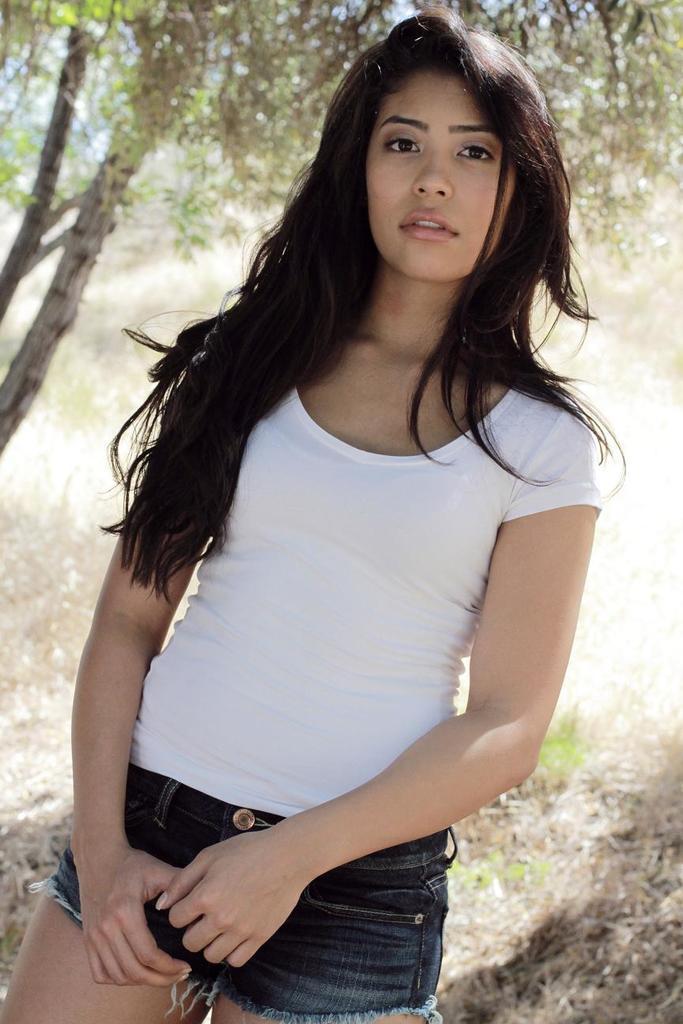Please provide a concise description of this image. In this image we can see a woman standing and wearing a white color t-shirt, also we can see the trees and the sky. 